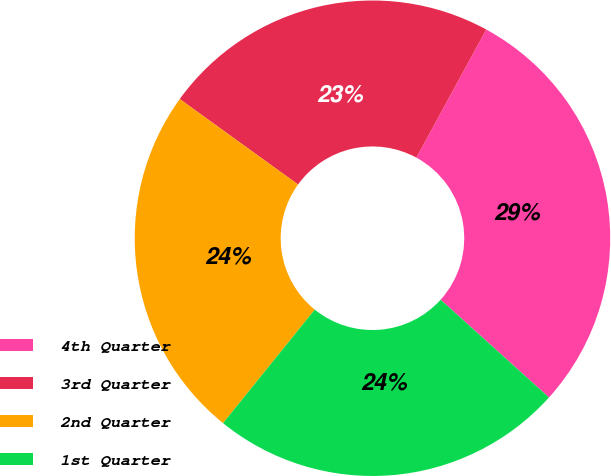Convert chart to OTSL. <chart><loc_0><loc_0><loc_500><loc_500><pie_chart><fcel>4th Quarter<fcel>3rd Quarter<fcel>2nd Quarter<fcel>1st Quarter<nl><fcel>28.74%<fcel>22.99%<fcel>24.14%<fcel>24.14%<nl></chart> 